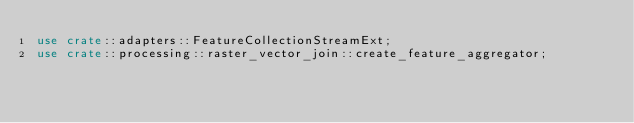Convert code to text. <code><loc_0><loc_0><loc_500><loc_500><_Rust_>use crate::adapters::FeatureCollectionStreamExt;
use crate::processing::raster_vector_join::create_feature_aggregator;</code> 